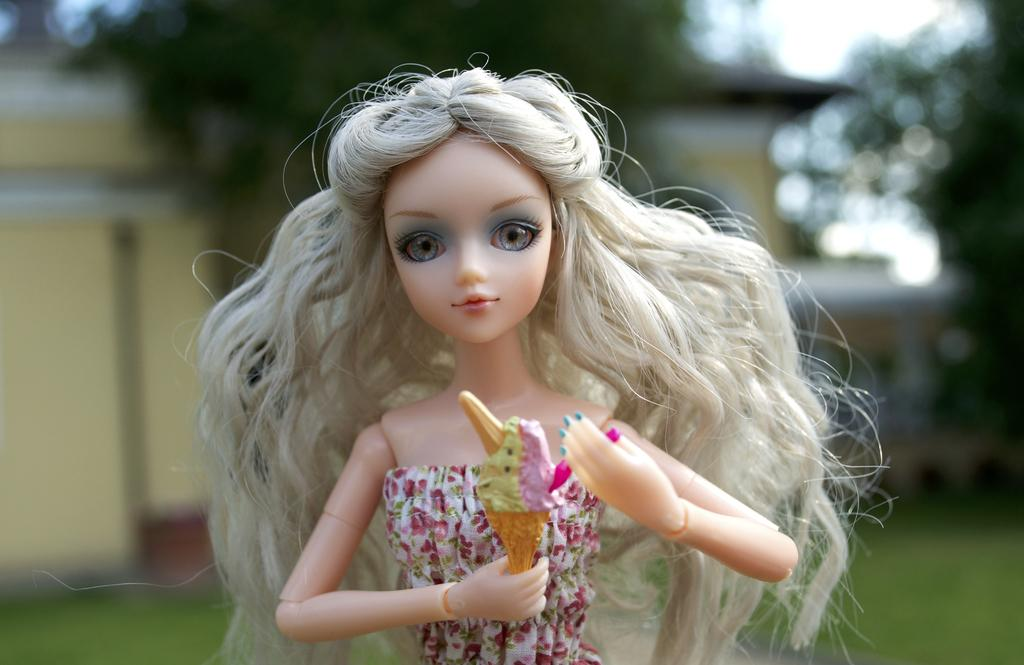What is the main subject in the image? There is a doll in the image. What is the doll holding in the image? The doll is holding an ice cream. Can you describe the background of the image? The background of the image is blurred. What type of card can be seen in the doll's hand in the image? There is no card present in the image; the doll is holding an ice cream. 